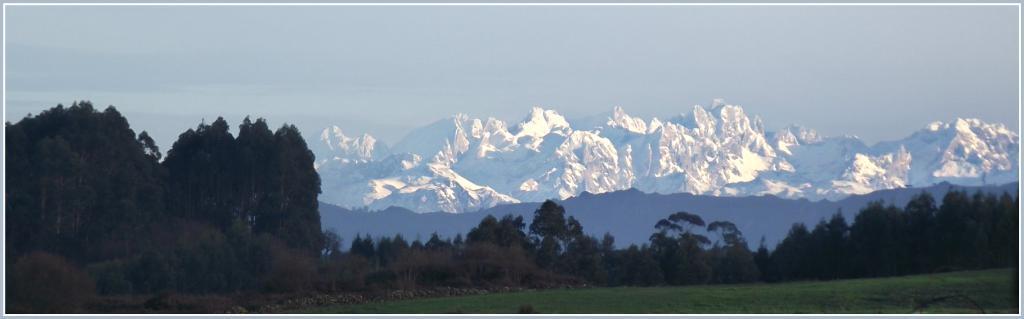Can you describe this image briefly? In this image there are few trees, stones, grass, mountains in which some of them are covered with snow and the sky. 